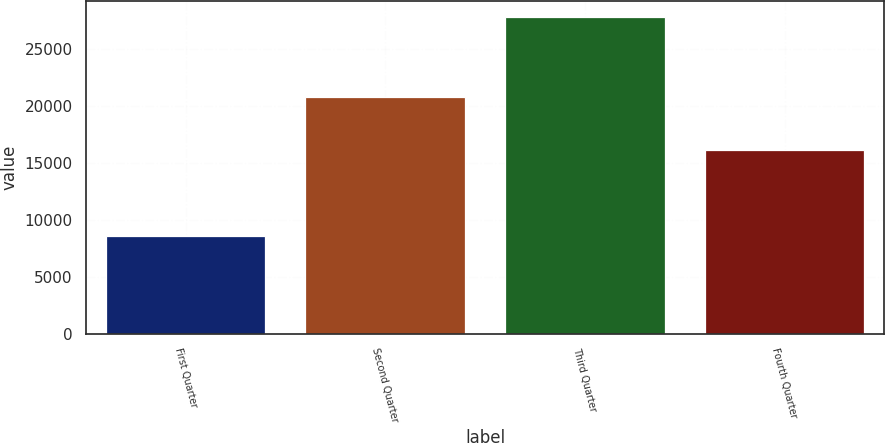<chart> <loc_0><loc_0><loc_500><loc_500><bar_chart><fcel>First Quarter<fcel>Second Quarter<fcel>Third Quarter<fcel>Fourth Quarter<nl><fcel>8637<fcel>20808<fcel>27873<fcel>16179<nl></chart> 